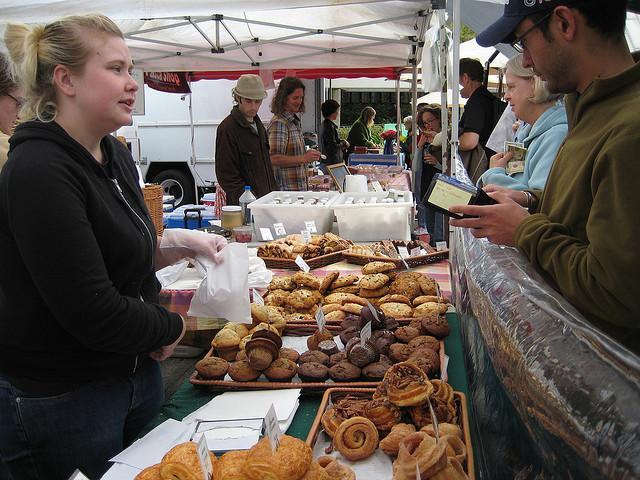Why is the woman on the left standing behind the table of pastries?
Select the accurate response from the four choices given to answer the question.
Options: She's buying, she's looking, she's selling, she's baking. She's selling. 